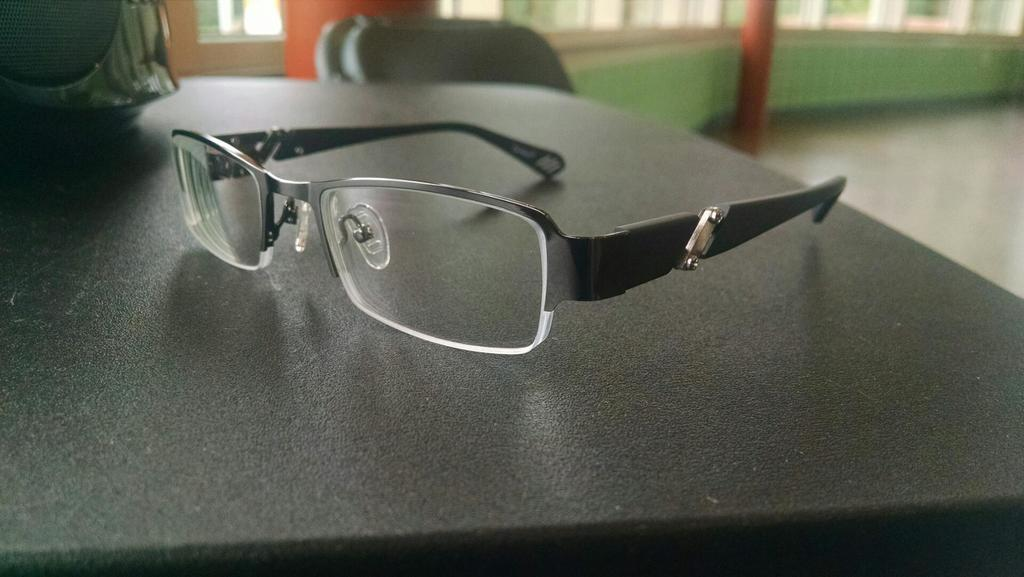What is the color of the surface that has specs on it? The surface with specs on it is black colored. What can be found on the black colored surface? There is an object on the black colored surface. What type of furniture is present in the image? There is a chair in the image. What allows natural light to enter the room in the image? There are windows in the image. How much pain is the paper experiencing in the image? There is no paper present in the image, so it cannot be experiencing any pain. 